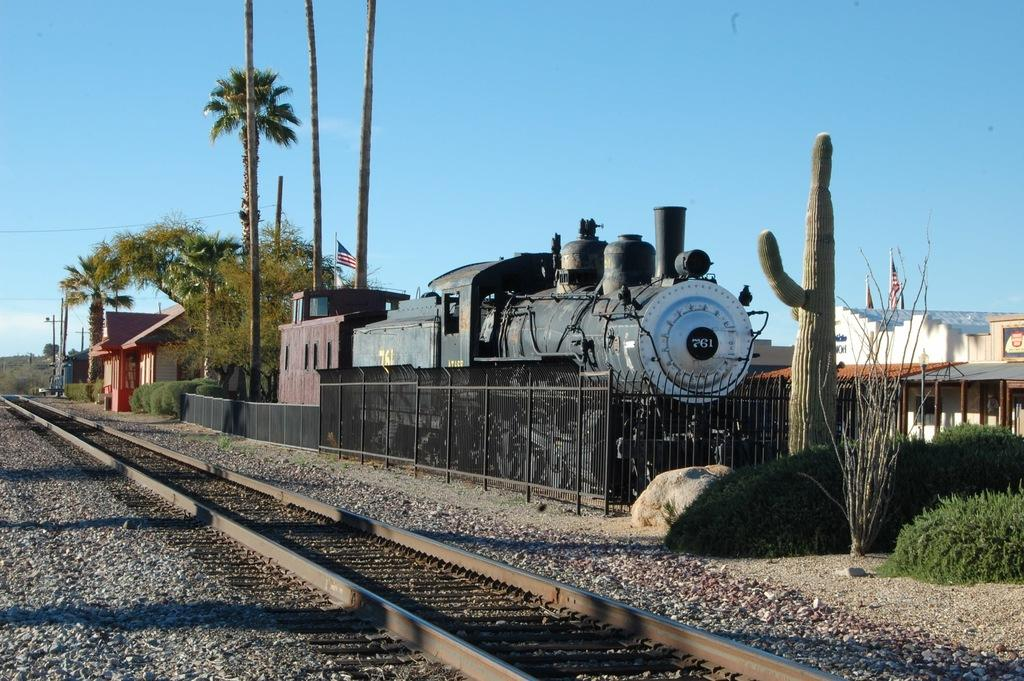What is the main subject of the image? The main subject of the image is a train. What can be seen alongside the train? There is a train track in the image. What type of vegetation is present in the image? There are trees in the image, and they are green. What other structures can be seen in the image? There are buildings and light poles in the image. What is the color of the sky in the image? The sky is blue in the image. Where is the map located in the image? There is no map present in the image. What type of pest can be seen crawling on the train in the image? There are no pests visible in the image; it features a train, train track, trees, buildings, light poles, and a blue sky. 